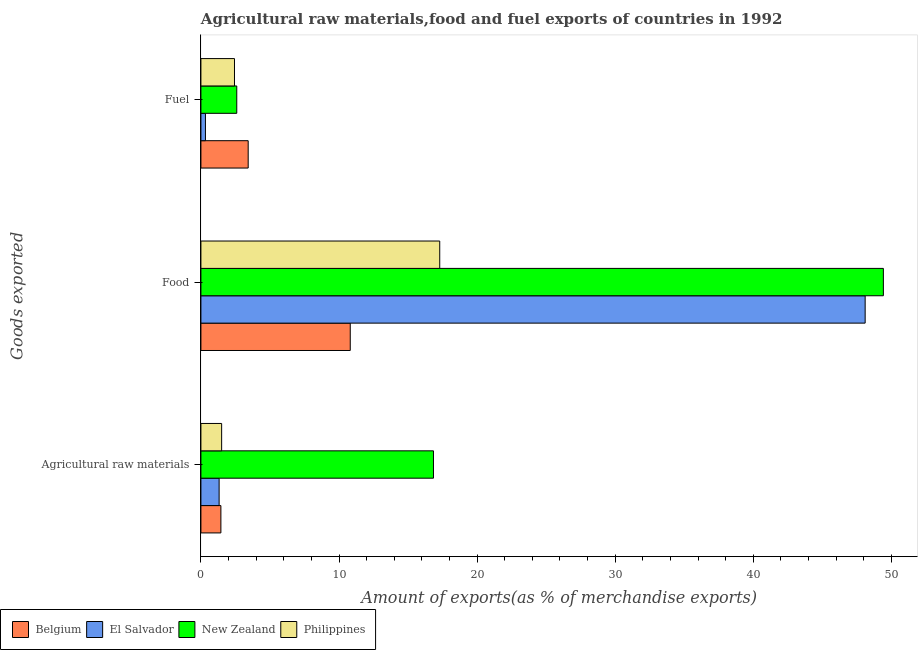How many groups of bars are there?
Offer a very short reply. 3. What is the label of the 3rd group of bars from the top?
Offer a very short reply. Agricultural raw materials. What is the percentage of raw materials exports in New Zealand?
Give a very brief answer. 16.84. Across all countries, what is the maximum percentage of raw materials exports?
Offer a very short reply. 16.84. Across all countries, what is the minimum percentage of raw materials exports?
Your answer should be very brief. 1.32. In which country was the percentage of fuel exports minimum?
Make the answer very short. El Salvador. What is the total percentage of raw materials exports in the graph?
Make the answer very short. 21.1. What is the difference between the percentage of fuel exports in Philippines and that in Belgium?
Your response must be concise. -0.99. What is the difference between the percentage of fuel exports in Belgium and the percentage of food exports in El Salvador?
Offer a very short reply. -44.68. What is the average percentage of raw materials exports per country?
Ensure brevity in your answer.  5.28. What is the difference between the percentage of fuel exports and percentage of raw materials exports in Belgium?
Offer a very short reply. 1.98. What is the ratio of the percentage of fuel exports in El Salvador to that in Philippines?
Offer a very short reply. 0.13. Is the difference between the percentage of food exports in Belgium and Philippines greater than the difference between the percentage of fuel exports in Belgium and Philippines?
Offer a very short reply. No. What is the difference between the highest and the second highest percentage of fuel exports?
Keep it short and to the point. 0.83. What is the difference between the highest and the lowest percentage of food exports?
Your answer should be compact. 38.6. In how many countries, is the percentage of raw materials exports greater than the average percentage of raw materials exports taken over all countries?
Offer a terse response. 1. What does the 4th bar from the bottom in Agricultural raw materials represents?
Give a very brief answer. Philippines. How many bars are there?
Give a very brief answer. 12. How many countries are there in the graph?
Your answer should be compact. 4. Are the values on the major ticks of X-axis written in scientific E-notation?
Your answer should be very brief. No. Where does the legend appear in the graph?
Your response must be concise. Bottom left. How many legend labels are there?
Give a very brief answer. 4. What is the title of the graph?
Provide a succinct answer. Agricultural raw materials,food and fuel exports of countries in 1992. Does "Togo" appear as one of the legend labels in the graph?
Keep it short and to the point. No. What is the label or title of the X-axis?
Provide a short and direct response. Amount of exports(as % of merchandise exports). What is the label or title of the Y-axis?
Give a very brief answer. Goods exported. What is the Amount of exports(as % of merchandise exports) of Belgium in Agricultural raw materials?
Offer a very short reply. 1.45. What is the Amount of exports(as % of merchandise exports) of El Salvador in Agricultural raw materials?
Give a very brief answer. 1.32. What is the Amount of exports(as % of merchandise exports) in New Zealand in Agricultural raw materials?
Provide a short and direct response. 16.84. What is the Amount of exports(as % of merchandise exports) of Philippines in Agricultural raw materials?
Give a very brief answer. 1.5. What is the Amount of exports(as % of merchandise exports) in Belgium in Food?
Ensure brevity in your answer.  10.81. What is the Amount of exports(as % of merchandise exports) of El Salvador in Food?
Your answer should be very brief. 48.1. What is the Amount of exports(as % of merchandise exports) of New Zealand in Food?
Provide a succinct answer. 49.42. What is the Amount of exports(as % of merchandise exports) of Philippines in Food?
Keep it short and to the point. 17.29. What is the Amount of exports(as % of merchandise exports) in Belgium in Fuel?
Keep it short and to the point. 3.42. What is the Amount of exports(as % of merchandise exports) of El Salvador in Fuel?
Provide a succinct answer. 0.33. What is the Amount of exports(as % of merchandise exports) of New Zealand in Fuel?
Offer a very short reply. 2.6. What is the Amount of exports(as % of merchandise exports) of Philippines in Fuel?
Offer a very short reply. 2.43. Across all Goods exported, what is the maximum Amount of exports(as % of merchandise exports) of Belgium?
Keep it short and to the point. 10.81. Across all Goods exported, what is the maximum Amount of exports(as % of merchandise exports) of El Salvador?
Provide a succinct answer. 48.1. Across all Goods exported, what is the maximum Amount of exports(as % of merchandise exports) in New Zealand?
Your response must be concise. 49.42. Across all Goods exported, what is the maximum Amount of exports(as % of merchandise exports) in Philippines?
Offer a terse response. 17.29. Across all Goods exported, what is the minimum Amount of exports(as % of merchandise exports) of Belgium?
Offer a very short reply. 1.45. Across all Goods exported, what is the minimum Amount of exports(as % of merchandise exports) in El Salvador?
Your answer should be very brief. 0.33. Across all Goods exported, what is the minimum Amount of exports(as % of merchandise exports) of New Zealand?
Make the answer very short. 2.6. Across all Goods exported, what is the minimum Amount of exports(as % of merchandise exports) in Philippines?
Give a very brief answer. 1.5. What is the total Amount of exports(as % of merchandise exports) of Belgium in the graph?
Your answer should be compact. 15.68. What is the total Amount of exports(as % of merchandise exports) in El Salvador in the graph?
Offer a very short reply. 49.74. What is the total Amount of exports(as % of merchandise exports) of New Zealand in the graph?
Keep it short and to the point. 68.85. What is the total Amount of exports(as % of merchandise exports) of Philippines in the graph?
Give a very brief answer. 21.22. What is the difference between the Amount of exports(as % of merchandise exports) of Belgium in Agricultural raw materials and that in Food?
Give a very brief answer. -9.37. What is the difference between the Amount of exports(as % of merchandise exports) of El Salvador in Agricultural raw materials and that in Food?
Keep it short and to the point. -46.78. What is the difference between the Amount of exports(as % of merchandise exports) of New Zealand in Agricultural raw materials and that in Food?
Give a very brief answer. -32.58. What is the difference between the Amount of exports(as % of merchandise exports) in Philippines in Agricultural raw materials and that in Food?
Keep it short and to the point. -15.79. What is the difference between the Amount of exports(as % of merchandise exports) in Belgium in Agricultural raw materials and that in Fuel?
Give a very brief answer. -1.98. What is the difference between the Amount of exports(as % of merchandise exports) of New Zealand in Agricultural raw materials and that in Fuel?
Make the answer very short. 14.24. What is the difference between the Amount of exports(as % of merchandise exports) in Philippines in Agricultural raw materials and that in Fuel?
Offer a very short reply. -0.93. What is the difference between the Amount of exports(as % of merchandise exports) in Belgium in Food and that in Fuel?
Keep it short and to the point. 7.39. What is the difference between the Amount of exports(as % of merchandise exports) of El Salvador in Food and that in Fuel?
Offer a terse response. 47.77. What is the difference between the Amount of exports(as % of merchandise exports) of New Zealand in Food and that in Fuel?
Keep it short and to the point. 46.82. What is the difference between the Amount of exports(as % of merchandise exports) of Philippines in Food and that in Fuel?
Your answer should be very brief. 14.86. What is the difference between the Amount of exports(as % of merchandise exports) of Belgium in Agricultural raw materials and the Amount of exports(as % of merchandise exports) of El Salvador in Food?
Offer a very short reply. -46.65. What is the difference between the Amount of exports(as % of merchandise exports) in Belgium in Agricultural raw materials and the Amount of exports(as % of merchandise exports) in New Zealand in Food?
Your answer should be compact. -47.97. What is the difference between the Amount of exports(as % of merchandise exports) of Belgium in Agricultural raw materials and the Amount of exports(as % of merchandise exports) of Philippines in Food?
Keep it short and to the point. -15.85. What is the difference between the Amount of exports(as % of merchandise exports) of El Salvador in Agricultural raw materials and the Amount of exports(as % of merchandise exports) of New Zealand in Food?
Keep it short and to the point. -48.1. What is the difference between the Amount of exports(as % of merchandise exports) in El Salvador in Agricultural raw materials and the Amount of exports(as % of merchandise exports) in Philippines in Food?
Make the answer very short. -15.98. What is the difference between the Amount of exports(as % of merchandise exports) in New Zealand in Agricultural raw materials and the Amount of exports(as % of merchandise exports) in Philippines in Food?
Provide a succinct answer. -0.45. What is the difference between the Amount of exports(as % of merchandise exports) of Belgium in Agricultural raw materials and the Amount of exports(as % of merchandise exports) of El Salvador in Fuel?
Keep it short and to the point. 1.12. What is the difference between the Amount of exports(as % of merchandise exports) of Belgium in Agricultural raw materials and the Amount of exports(as % of merchandise exports) of New Zealand in Fuel?
Offer a very short reply. -1.15. What is the difference between the Amount of exports(as % of merchandise exports) in Belgium in Agricultural raw materials and the Amount of exports(as % of merchandise exports) in Philippines in Fuel?
Provide a succinct answer. -0.99. What is the difference between the Amount of exports(as % of merchandise exports) of El Salvador in Agricultural raw materials and the Amount of exports(as % of merchandise exports) of New Zealand in Fuel?
Your answer should be very brief. -1.28. What is the difference between the Amount of exports(as % of merchandise exports) in El Salvador in Agricultural raw materials and the Amount of exports(as % of merchandise exports) in Philippines in Fuel?
Your answer should be very brief. -1.11. What is the difference between the Amount of exports(as % of merchandise exports) in New Zealand in Agricultural raw materials and the Amount of exports(as % of merchandise exports) in Philippines in Fuel?
Offer a very short reply. 14.41. What is the difference between the Amount of exports(as % of merchandise exports) of Belgium in Food and the Amount of exports(as % of merchandise exports) of El Salvador in Fuel?
Give a very brief answer. 10.48. What is the difference between the Amount of exports(as % of merchandise exports) in Belgium in Food and the Amount of exports(as % of merchandise exports) in New Zealand in Fuel?
Ensure brevity in your answer.  8.22. What is the difference between the Amount of exports(as % of merchandise exports) in Belgium in Food and the Amount of exports(as % of merchandise exports) in Philippines in Fuel?
Your response must be concise. 8.38. What is the difference between the Amount of exports(as % of merchandise exports) of El Salvador in Food and the Amount of exports(as % of merchandise exports) of New Zealand in Fuel?
Provide a short and direct response. 45.5. What is the difference between the Amount of exports(as % of merchandise exports) in El Salvador in Food and the Amount of exports(as % of merchandise exports) in Philippines in Fuel?
Provide a succinct answer. 45.67. What is the difference between the Amount of exports(as % of merchandise exports) of New Zealand in Food and the Amount of exports(as % of merchandise exports) of Philippines in Fuel?
Offer a very short reply. 46.99. What is the average Amount of exports(as % of merchandise exports) in Belgium per Goods exported?
Offer a very short reply. 5.23. What is the average Amount of exports(as % of merchandise exports) of El Salvador per Goods exported?
Ensure brevity in your answer.  16.58. What is the average Amount of exports(as % of merchandise exports) of New Zealand per Goods exported?
Provide a succinct answer. 22.95. What is the average Amount of exports(as % of merchandise exports) in Philippines per Goods exported?
Provide a succinct answer. 7.07. What is the difference between the Amount of exports(as % of merchandise exports) of Belgium and Amount of exports(as % of merchandise exports) of El Salvador in Agricultural raw materials?
Offer a very short reply. 0.13. What is the difference between the Amount of exports(as % of merchandise exports) in Belgium and Amount of exports(as % of merchandise exports) in New Zealand in Agricultural raw materials?
Give a very brief answer. -15.39. What is the difference between the Amount of exports(as % of merchandise exports) of Belgium and Amount of exports(as % of merchandise exports) of Philippines in Agricultural raw materials?
Your answer should be compact. -0.05. What is the difference between the Amount of exports(as % of merchandise exports) of El Salvador and Amount of exports(as % of merchandise exports) of New Zealand in Agricultural raw materials?
Provide a short and direct response. -15.52. What is the difference between the Amount of exports(as % of merchandise exports) in El Salvador and Amount of exports(as % of merchandise exports) in Philippines in Agricultural raw materials?
Provide a short and direct response. -0.18. What is the difference between the Amount of exports(as % of merchandise exports) in New Zealand and Amount of exports(as % of merchandise exports) in Philippines in Agricultural raw materials?
Your answer should be compact. 15.34. What is the difference between the Amount of exports(as % of merchandise exports) of Belgium and Amount of exports(as % of merchandise exports) of El Salvador in Food?
Give a very brief answer. -37.28. What is the difference between the Amount of exports(as % of merchandise exports) in Belgium and Amount of exports(as % of merchandise exports) in New Zealand in Food?
Keep it short and to the point. -38.6. What is the difference between the Amount of exports(as % of merchandise exports) in Belgium and Amount of exports(as % of merchandise exports) in Philippines in Food?
Offer a terse response. -6.48. What is the difference between the Amount of exports(as % of merchandise exports) in El Salvador and Amount of exports(as % of merchandise exports) in New Zealand in Food?
Your answer should be very brief. -1.32. What is the difference between the Amount of exports(as % of merchandise exports) of El Salvador and Amount of exports(as % of merchandise exports) of Philippines in Food?
Ensure brevity in your answer.  30.8. What is the difference between the Amount of exports(as % of merchandise exports) in New Zealand and Amount of exports(as % of merchandise exports) in Philippines in Food?
Make the answer very short. 32.12. What is the difference between the Amount of exports(as % of merchandise exports) of Belgium and Amount of exports(as % of merchandise exports) of El Salvador in Fuel?
Provide a short and direct response. 3.09. What is the difference between the Amount of exports(as % of merchandise exports) in Belgium and Amount of exports(as % of merchandise exports) in New Zealand in Fuel?
Offer a terse response. 0.83. What is the difference between the Amount of exports(as % of merchandise exports) in Belgium and Amount of exports(as % of merchandise exports) in Philippines in Fuel?
Your answer should be compact. 0.99. What is the difference between the Amount of exports(as % of merchandise exports) of El Salvador and Amount of exports(as % of merchandise exports) of New Zealand in Fuel?
Keep it short and to the point. -2.27. What is the difference between the Amount of exports(as % of merchandise exports) of El Salvador and Amount of exports(as % of merchandise exports) of Philippines in Fuel?
Your response must be concise. -2.1. What is the difference between the Amount of exports(as % of merchandise exports) of New Zealand and Amount of exports(as % of merchandise exports) of Philippines in Fuel?
Your response must be concise. 0.17. What is the ratio of the Amount of exports(as % of merchandise exports) of Belgium in Agricultural raw materials to that in Food?
Make the answer very short. 0.13. What is the ratio of the Amount of exports(as % of merchandise exports) in El Salvador in Agricultural raw materials to that in Food?
Your response must be concise. 0.03. What is the ratio of the Amount of exports(as % of merchandise exports) of New Zealand in Agricultural raw materials to that in Food?
Your response must be concise. 0.34. What is the ratio of the Amount of exports(as % of merchandise exports) in Philippines in Agricultural raw materials to that in Food?
Ensure brevity in your answer.  0.09. What is the ratio of the Amount of exports(as % of merchandise exports) in Belgium in Agricultural raw materials to that in Fuel?
Provide a succinct answer. 0.42. What is the ratio of the Amount of exports(as % of merchandise exports) of El Salvador in Agricultural raw materials to that in Fuel?
Provide a succinct answer. 4.02. What is the ratio of the Amount of exports(as % of merchandise exports) in New Zealand in Agricultural raw materials to that in Fuel?
Offer a very short reply. 6.49. What is the ratio of the Amount of exports(as % of merchandise exports) of Philippines in Agricultural raw materials to that in Fuel?
Keep it short and to the point. 0.62. What is the ratio of the Amount of exports(as % of merchandise exports) of Belgium in Food to that in Fuel?
Provide a succinct answer. 3.16. What is the ratio of the Amount of exports(as % of merchandise exports) of El Salvador in Food to that in Fuel?
Your answer should be very brief. 146.56. What is the ratio of the Amount of exports(as % of merchandise exports) of New Zealand in Food to that in Fuel?
Give a very brief answer. 19.03. What is the ratio of the Amount of exports(as % of merchandise exports) in Philippines in Food to that in Fuel?
Keep it short and to the point. 7.11. What is the difference between the highest and the second highest Amount of exports(as % of merchandise exports) in Belgium?
Your answer should be very brief. 7.39. What is the difference between the highest and the second highest Amount of exports(as % of merchandise exports) of El Salvador?
Your response must be concise. 46.78. What is the difference between the highest and the second highest Amount of exports(as % of merchandise exports) of New Zealand?
Keep it short and to the point. 32.58. What is the difference between the highest and the second highest Amount of exports(as % of merchandise exports) in Philippines?
Your answer should be compact. 14.86. What is the difference between the highest and the lowest Amount of exports(as % of merchandise exports) of Belgium?
Your answer should be compact. 9.37. What is the difference between the highest and the lowest Amount of exports(as % of merchandise exports) in El Salvador?
Give a very brief answer. 47.77. What is the difference between the highest and the lowest Amount of exports(as % of merchandise exports) of New Zealand?
Keep it short and to the point. 46.82. What is the difference between the highest and the lowest Amount of exports(as % of merchandise exports) of Philippines?
Ensure brevity in your answer.  15.79. 